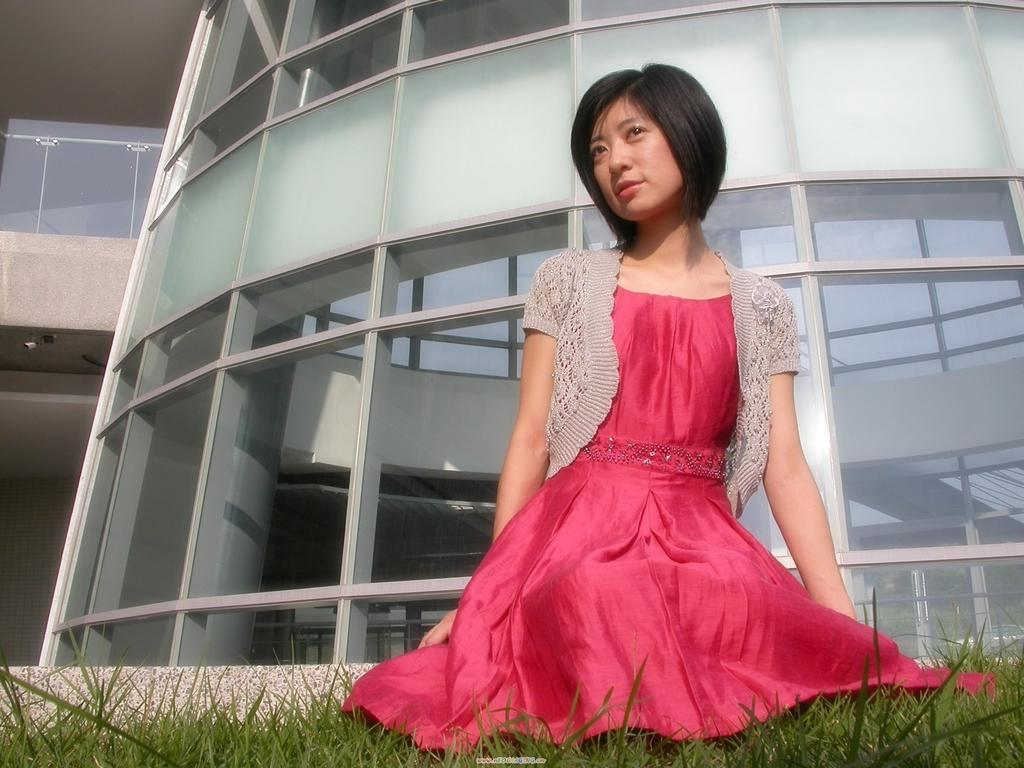Who is present in the image? There is a woman in the image. What type of surface is at the bottom of the image? There is grass at the bottom of the image. What can be seen in the distance in the image? There is a building in the background of the image. What object is visible in the image that might be used for drinking? There is a glass in the image. What color is the woman's eye in the image? The facts provided do not mention the color of the woman's eye, so we cannot determine the color from the image. 